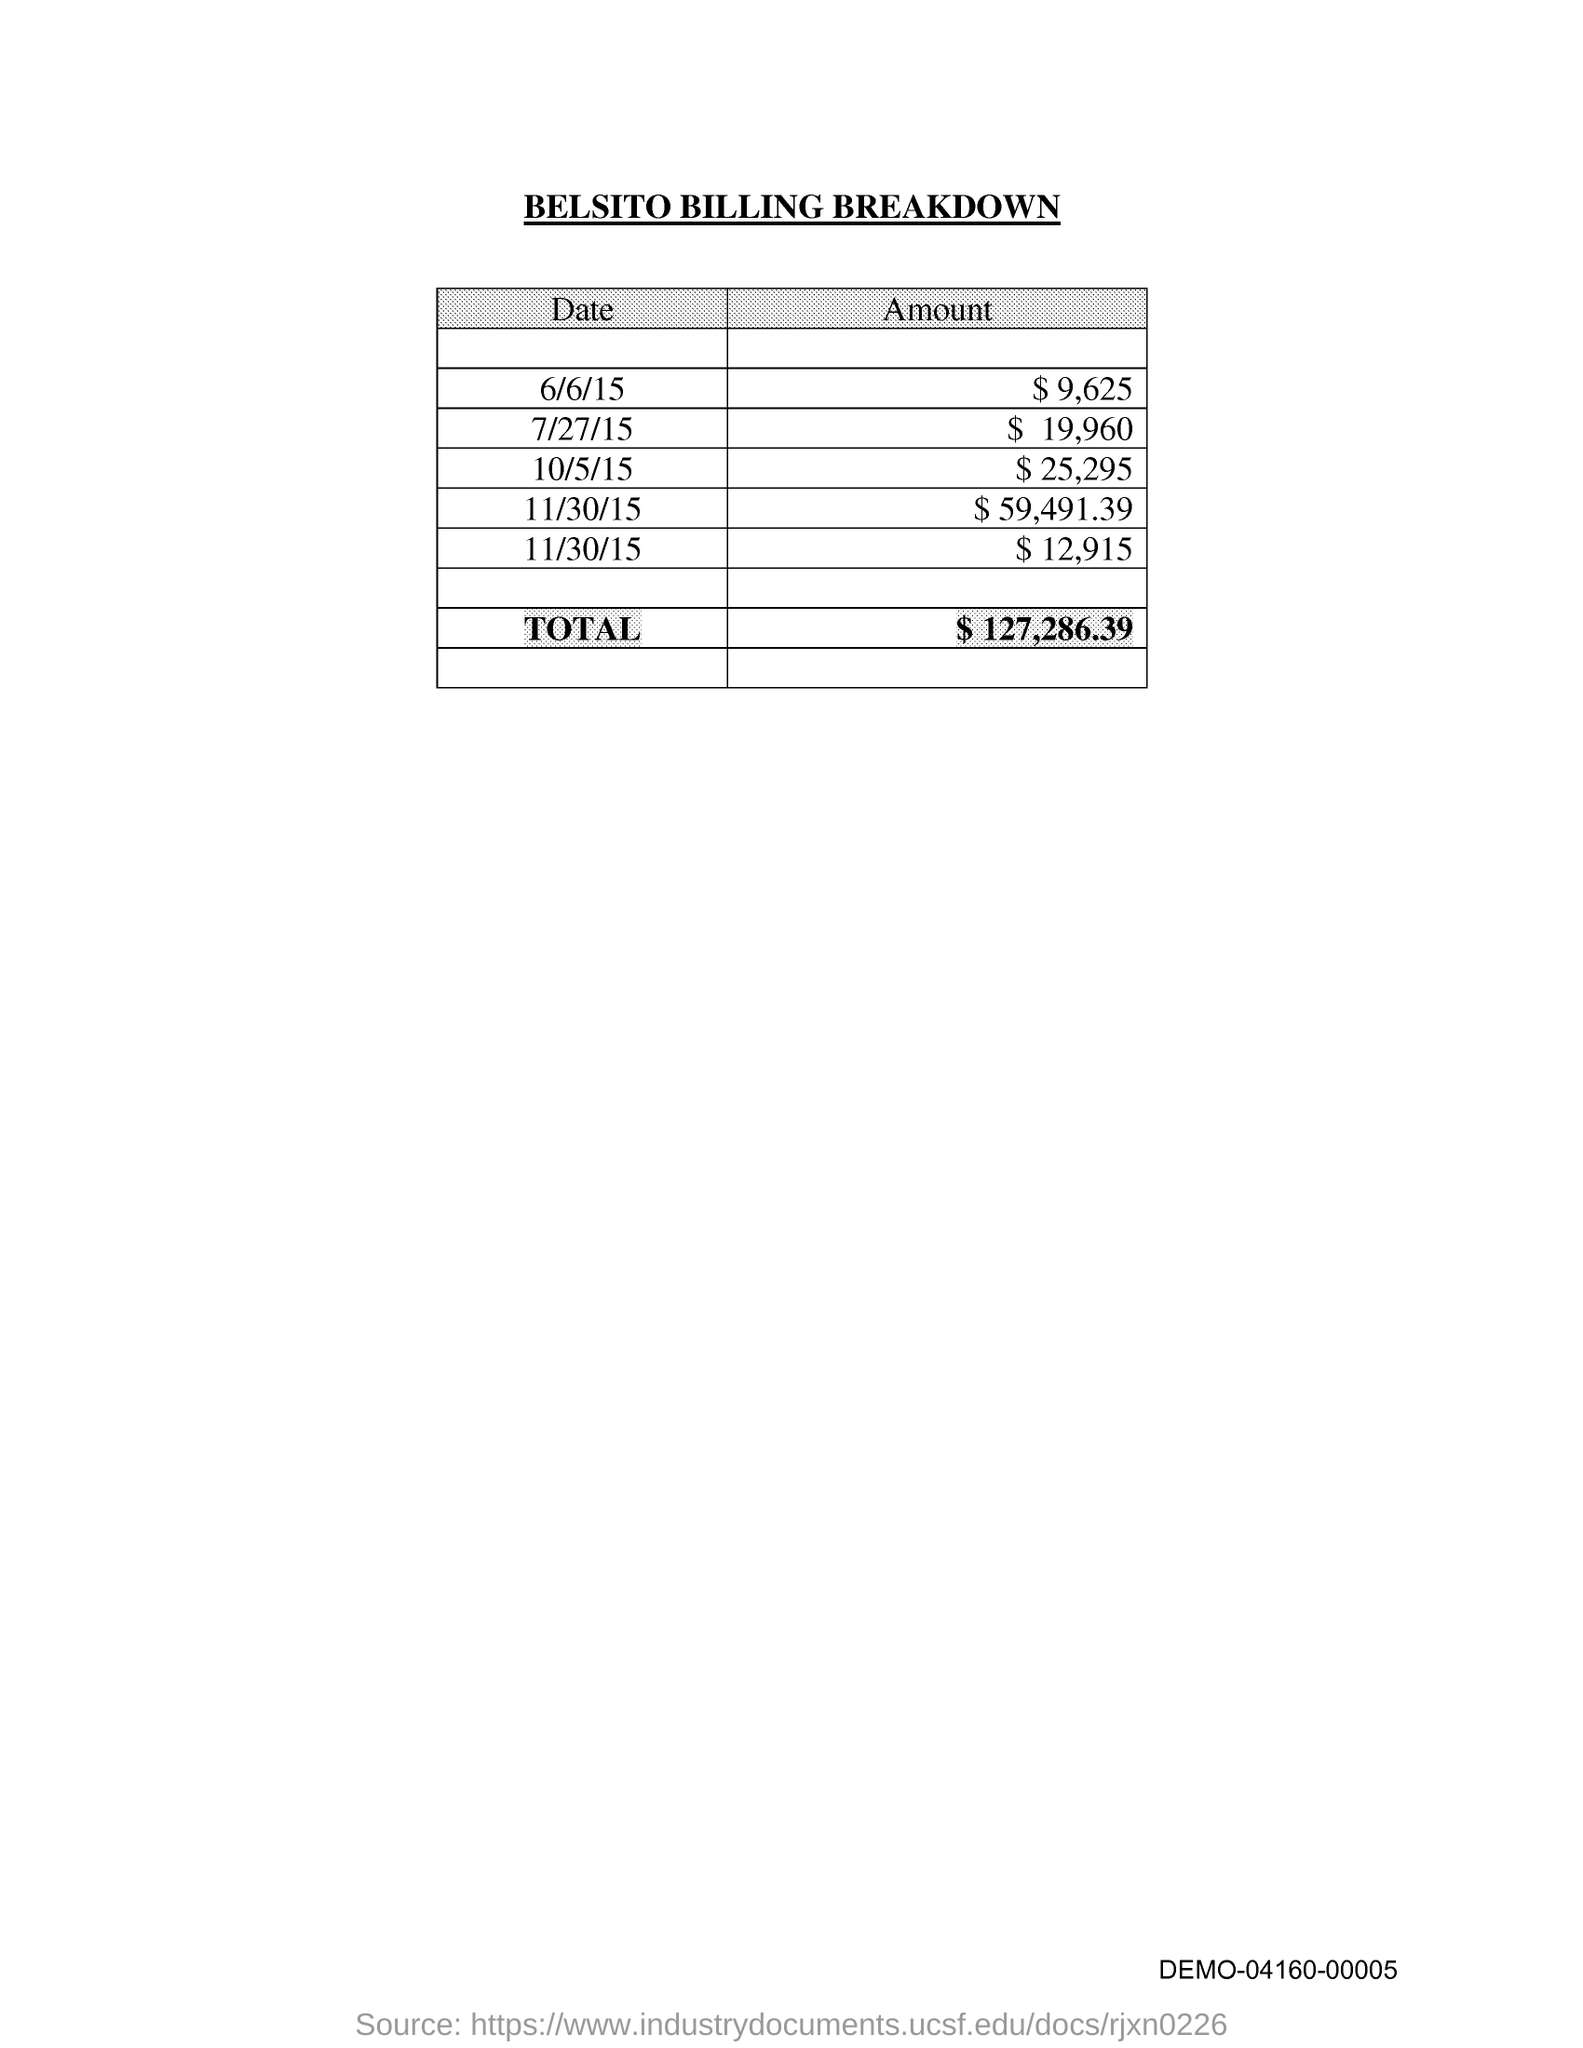Outline some significant characteristics in this image. On June 6, 2015, the amount was $9,625. The total amount is $127,286.39. On July 27, 2015, the amount was $19,960. On October 5, 2015, the amount was $25,295. The title of the document is "Belsito Billing Breakdown. 